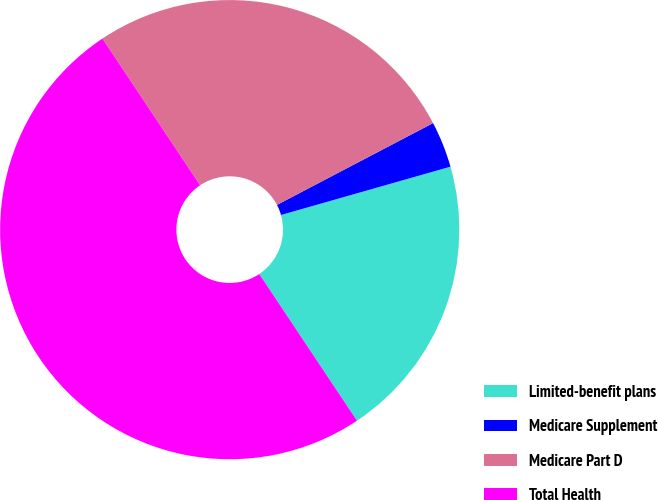<chart> <loc_0><loc_0><loc_500><loc_500><pie_chart><fcel>Limited-benefit plans<fcel>Medicare Supplement<fcel>Medicare Part D<fcel>Total Health<nl><fcel>20.07%<fcel>3.26%<fcel>26.67%<fcel>50.0%<nl></chart> 